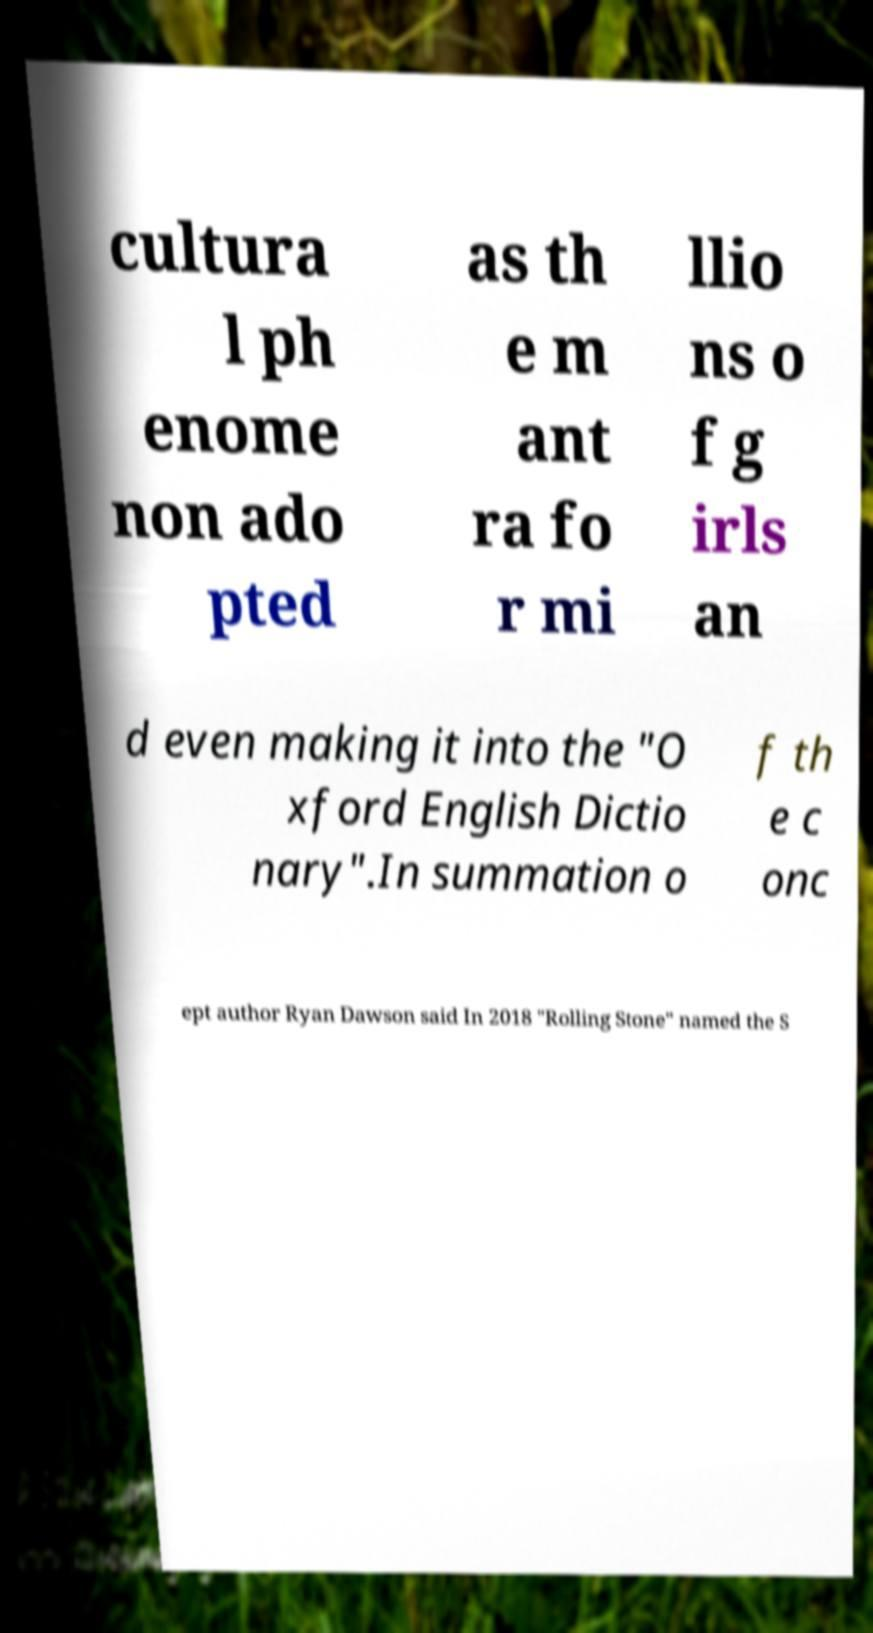Could you extract and type out the text from this image? cultura l ph enome non ado pted as th e m ant ra fo r mi llio ns o f g irls an d even making it into the "O xford English Dictio nary".In summation o f th e c onc ept author Ryan Dawson said In 2018 "Rolling Stone" named the S 